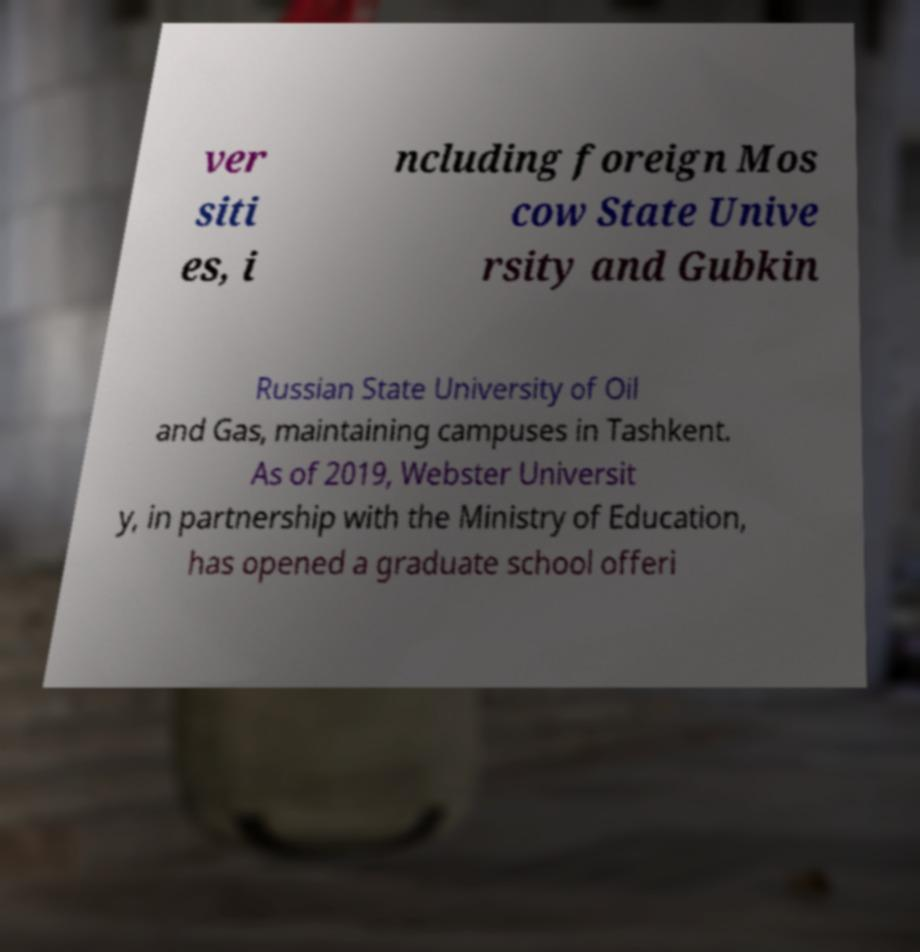What messages or text are displayed in this image? I need them in a readable, typed format. ver siti es, i ncluding foreign Mos cow State Unive rsity and Gubkin Russian State University of Oil and Gas, maintaining campuses in Tashkent. As of 2019, Webster Universit y, in partnership with the Ministry of Education, has opened a graduate school offeri 